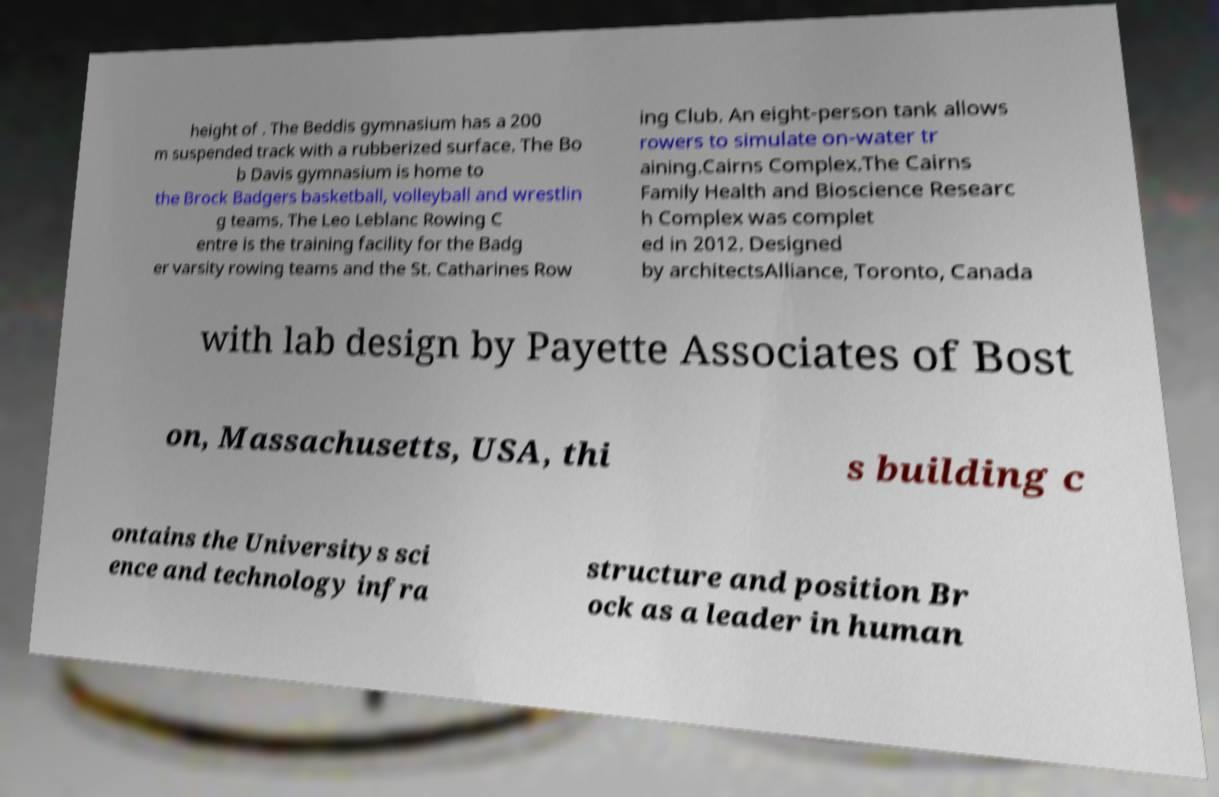There's text embedded in this image that I need extracted. Can you transcribe it verbatim? height of . The Beddis gymnasium has a 200 m suspended track with a rubberized surface. The Bo b Davis gymnasium is home to the Brock Badgers basketball, volleyball and wrestlin g teams. The Leo Leblanc Rowing C entre is the training facility for the Badg er varsity rowing teams and the St. Catharines Row ing Club. An eight-person tank allows rowers to simulate on-water tr aining.Cairns Complex.The Cairns Family Health and Bioscience Researc h Complex was complet ed in 2012. Designed by architectsAlliance, Toronto, Canada with lab design by Payette Associates of Bost on, Massachusetts, USA, thi s building c ontains the Universitys sci ence and technology infra structure and position Br ock as a leader in human 